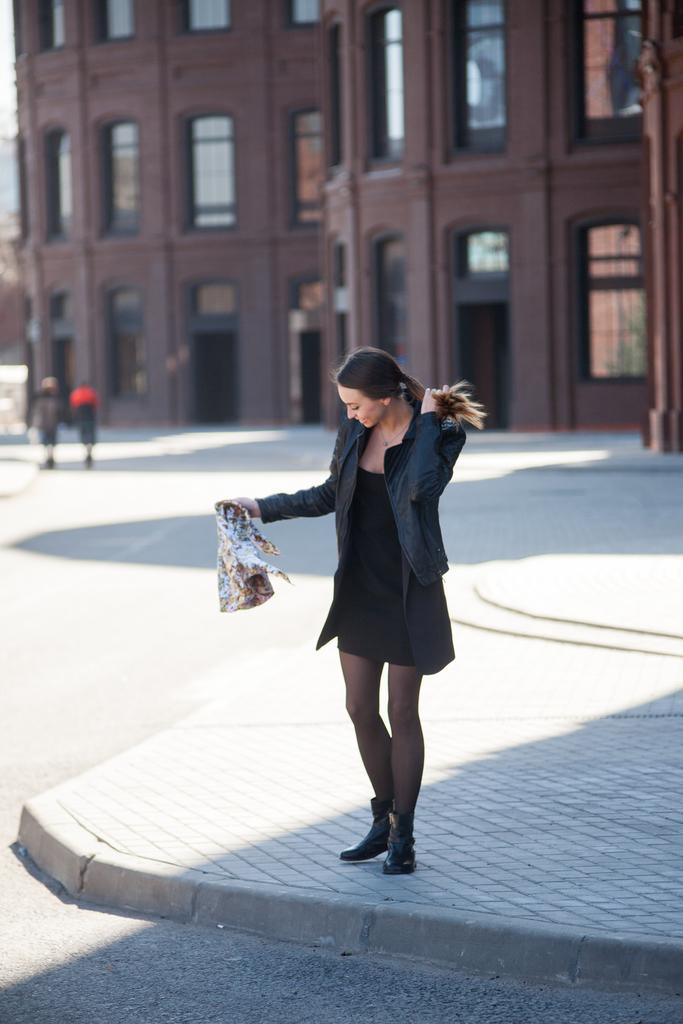What is the woman doing in the image? The woman is standing on a platform in the image. What else can be seen in the image besides the woman? There is a road and two persons visible in the image. What is located in the background of the image? There is a building in the background of the image. What type of acoustics can be heard from the seashore in the image? There is no seashore present in the image, and therefore no acoustics can be heard from it. 